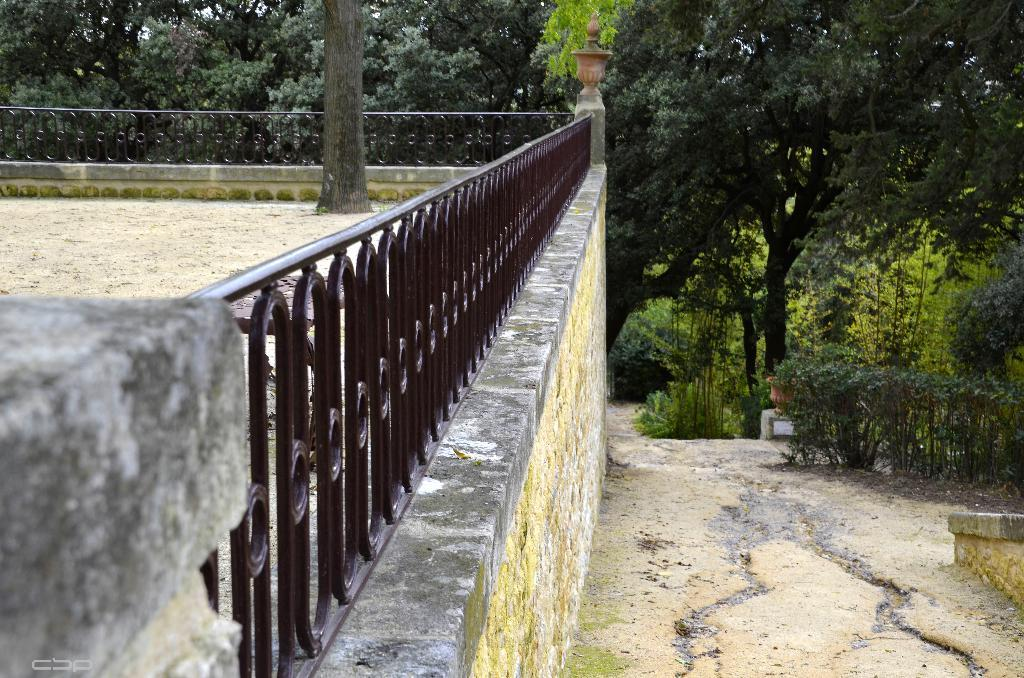What is located on the left side of the image? There is a wall, fencing, sand, and a tree on the left side of the image. What can be seen in the background of the image? There are plants and trees in the background of the image. Where is the plastic bucket located in the image? There is no plastic bucket present in the image. What type of table can be seen in the image? There is no table present in the image. 